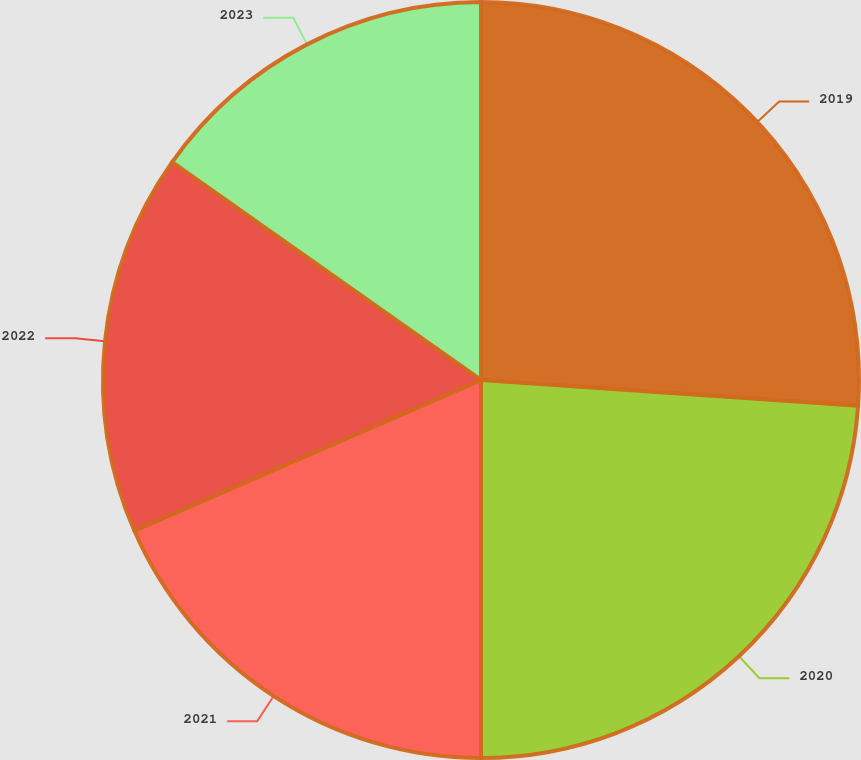<chart> <loc_0><loc_0><loc_500><loc_500><pie_chart><fcel>2019<fcel>2020<fcel>2021<fcel>2022<fcel>2023<nl><fcel>26.09%<fcel>23.91%<fcel>18.48%<fcel>16.3%<fcel>15.22%<nl></chart> 